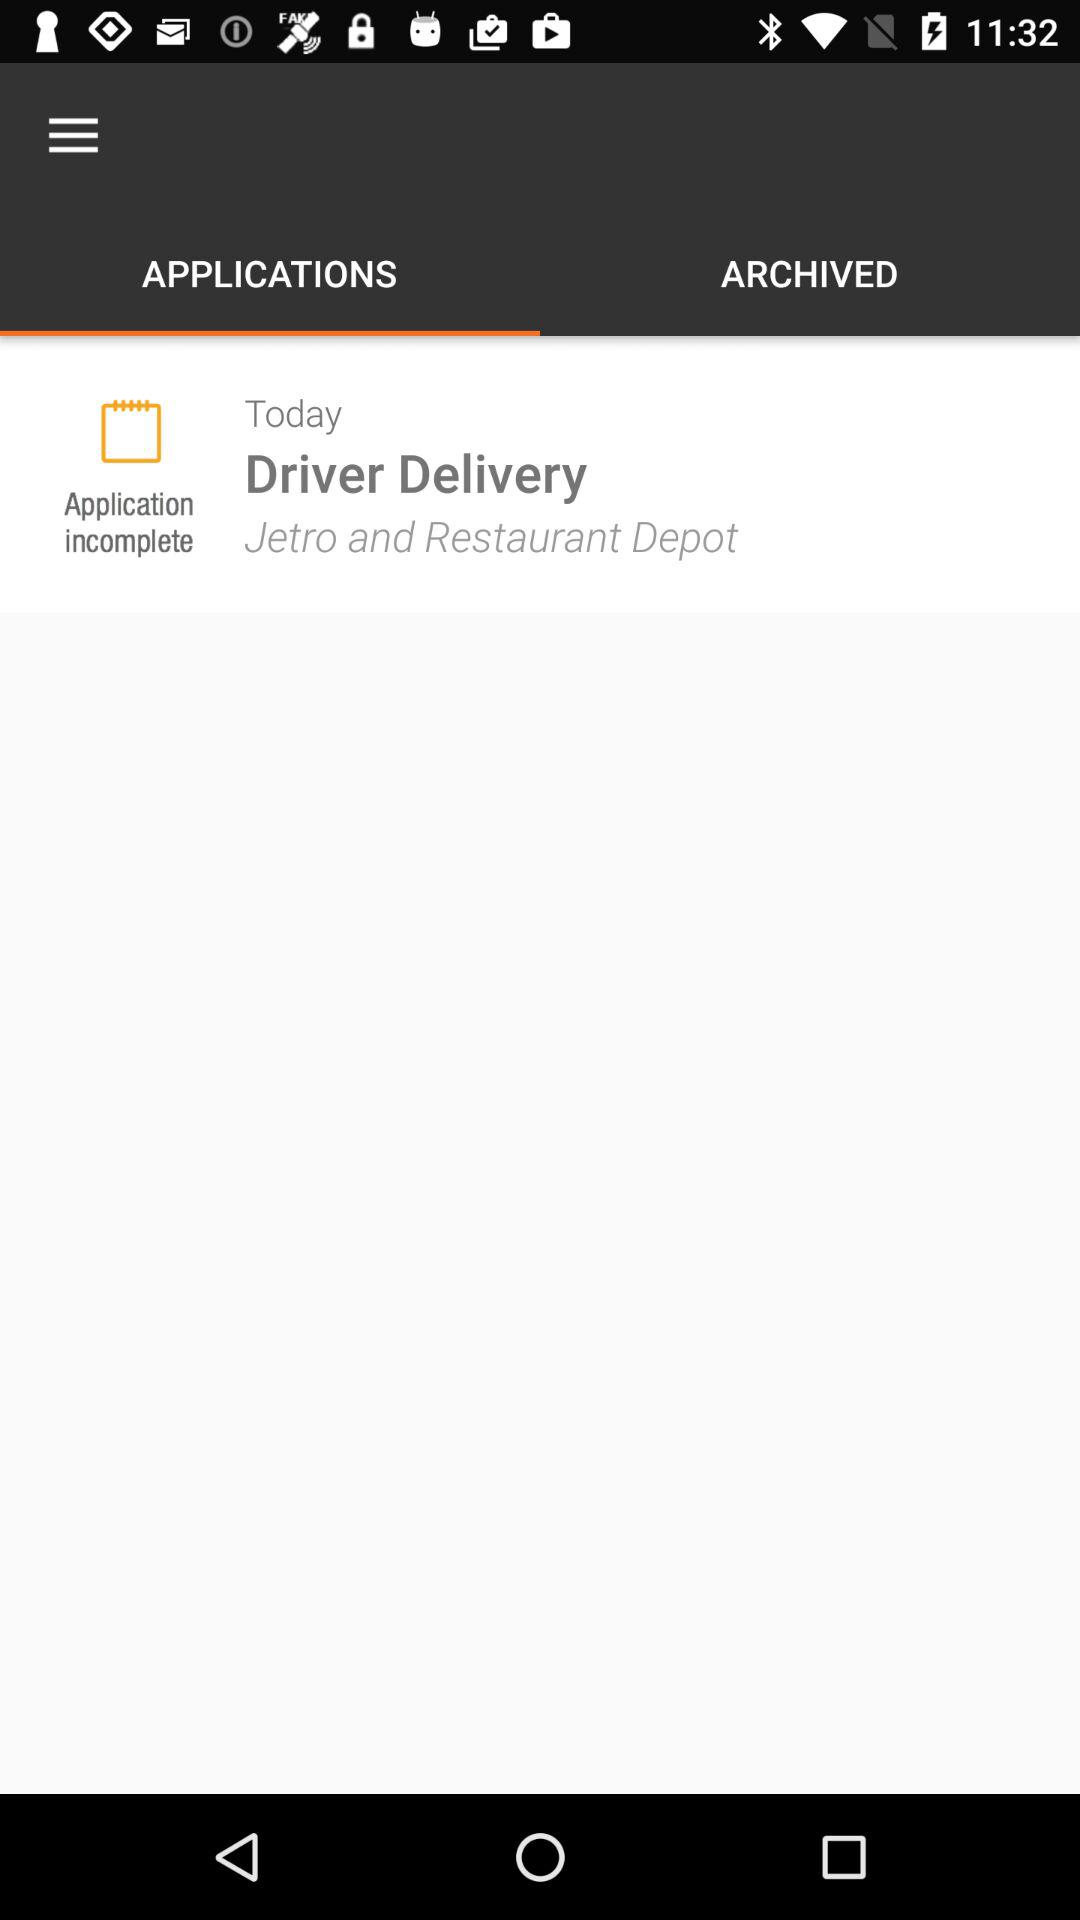What is the day of delivery by the driver? The day of delivery by the driver is today. 